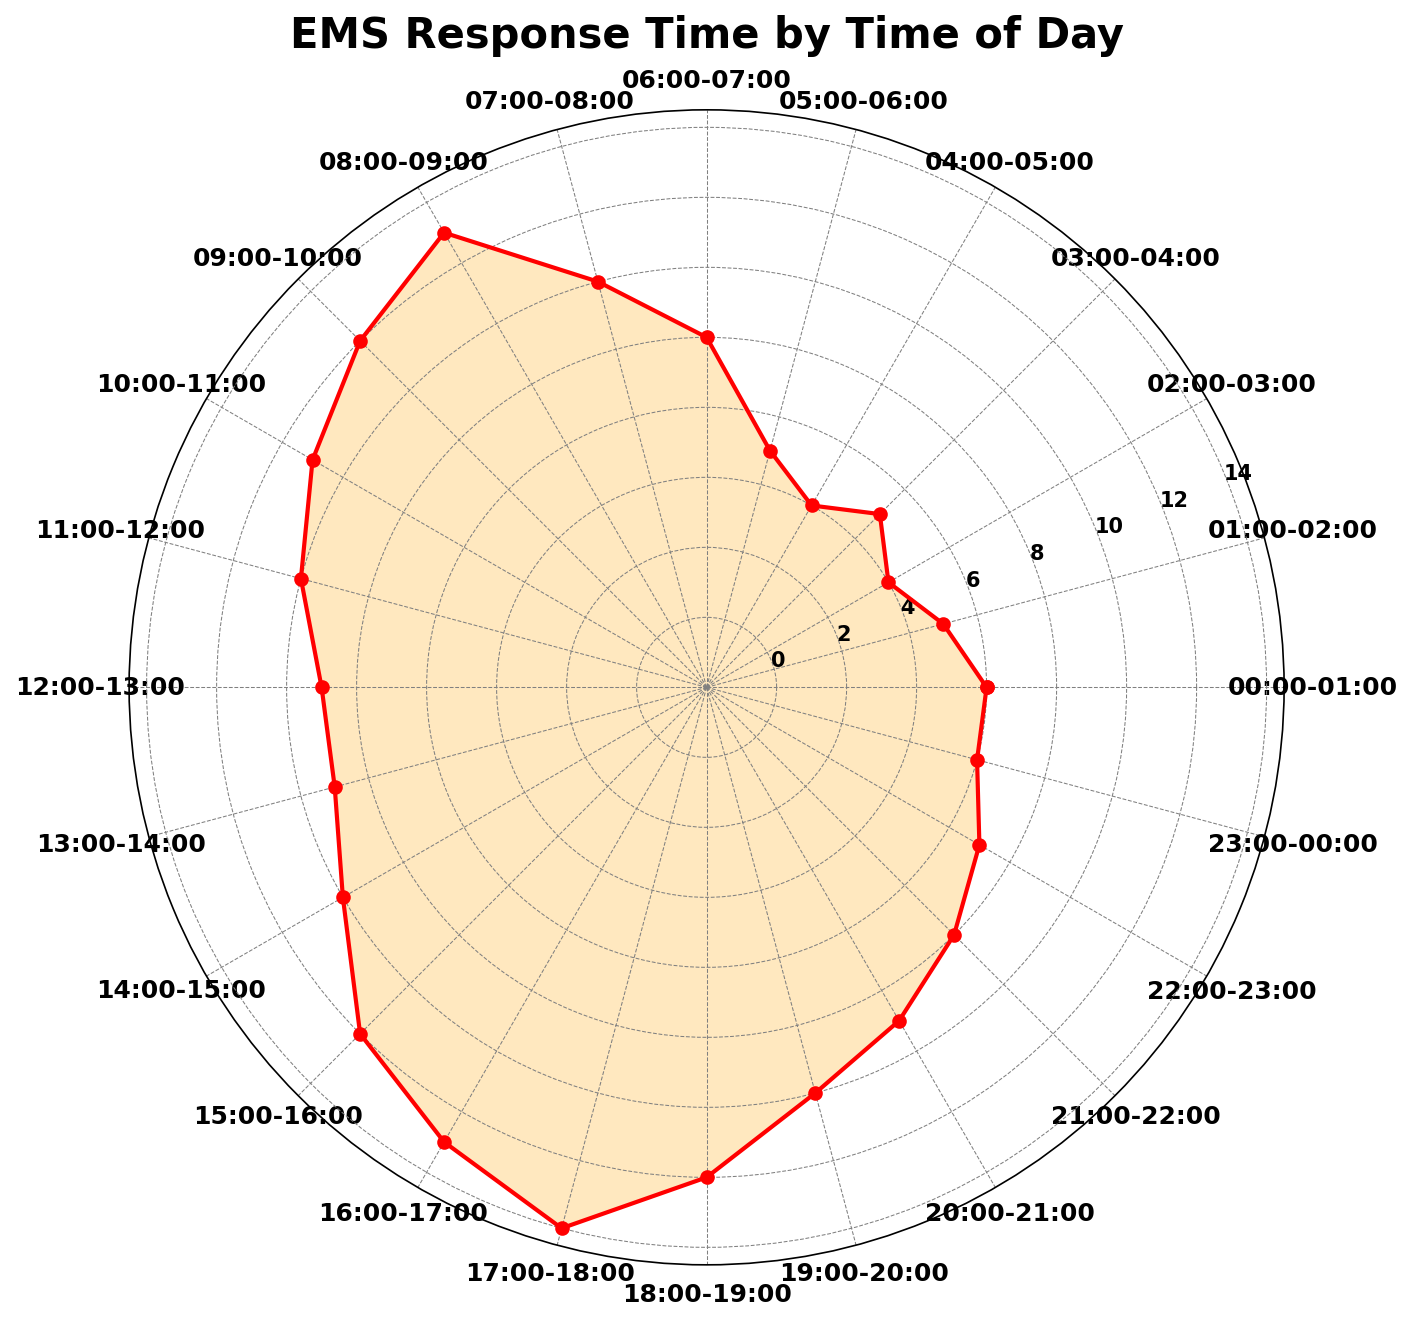What time of day has the shortest EMS response time? To identify the time of day with the shortest response time, check the length of the segments in the rose chart. The shortest segment corresponds to the smallest number, which visually is between 02:00-03:00 and 04:00-05:00. Both segments have the same length indicating a response time of 6 minutes.
Answer: 02:00-03:00 and 04:00-05:00 What time of day has the longest EMS response time? To identify the time of day with the longest EMS response time, look for the longest segment in the rose chart. The longest segment is from 17:00-18:00 with a response time of 16 minutes.
Answer: 17:00-18:00 How does the response time at 08:00-09:00 compare to 22:00-23:00? To compare the response times, check the lengths of the segments. At 08:00-09:00, the response time is 15 minutes, and at 22:00-23:00, it is 9 minutes. Therefore, the response time at 08:00-09:00 is longer.
Answer: 08:00-09:00 is longer What's the average EMS response time between 06:00 and 12:00? To find the average response time between 06:00 and 12:00, sum the response times for each hour in that range and divide by the number of hours. The response times are 10, 12, 15, 14, 13, and 12. Sum them up: 10 + 12 + 15 + 14 + 13 + 12 = 76. There are 6 hours in this range, so the average is 76/6 = 12.67 minutes.
Answer: 12.67 Which range has more variability in response times, 00:00-06:00 or 17:00-23:00? To determine variability, observe the range of response times in both periods. From 00:00-06:00, the response times vary between 6 and 10 minutes (a range of 4 minutes). From 17:00-23:00, response times vary from 8 to 16 minutes (a range of 8 minutes), indicating greater variability.
Answer: 17:00-23:00 At what time range does the EMS response time start to significantly increase from the early morning? To find when the response time starts to increase significantly, observe the trend in the chart from early morning onwards. From 05:00-06:00 (7 minutes) to 06:00-07:00 (10 minutes) and then 07:00-08:00 (12 minutes) shows a noticeable increase around 06:00-07:00.
Answer: 06:00-07:00 How do the response times between 12:00-16:00 compare with those between 20:00-00:00? Calculate the average response time for each period. For 12:00-16:00: 11, 11, 12, 14, 15. Sum = 11 + 11 + 12 + 14 + 15 = 63. Average = 63/5 = 12.6 minutes. For 20:00-00:00: 11, 10, 9, 8 = 38. Average = 38/4 = 9.5 minutes. Therefore, the period 12:00-16:00 has a higher average response time.
Answer: 12:00-16:00 is higher 